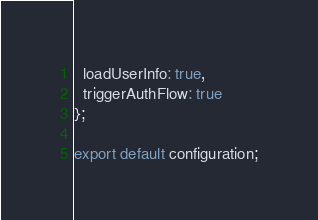Convert code to text. <code><loc_0><loc_0><loc_500><loc_500><_JavaScript_>  loadUserInfo: true,
  triggerAuthFlow: true
};

export default configuration;
</code> 